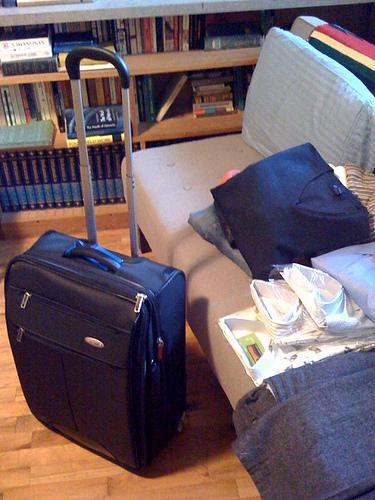Question: what type of flooring is underneath the suitcase?
Choices:
A. Wood.
B. Cermanic tile.
C. Stone flooring.
D. Concrete.
Answer with the letter. Answer: A Question: how many shelves does the bookshelf have?
Choices:
A. Three.
B. Two.
C. Four.
D. Five.
Answer with the letter. Answer: A Question: where was this photo taken?
Choices:
A. In a living room.
B. In the attic.
C. In the basement.
D. In a garage.
Answer with the letter. Answer: A Question: how many zippers does the suitcase have?
Choices:
A. Three.
B. Two.
C. Four.
D. Five.
Answer with the letter. Answer: A 